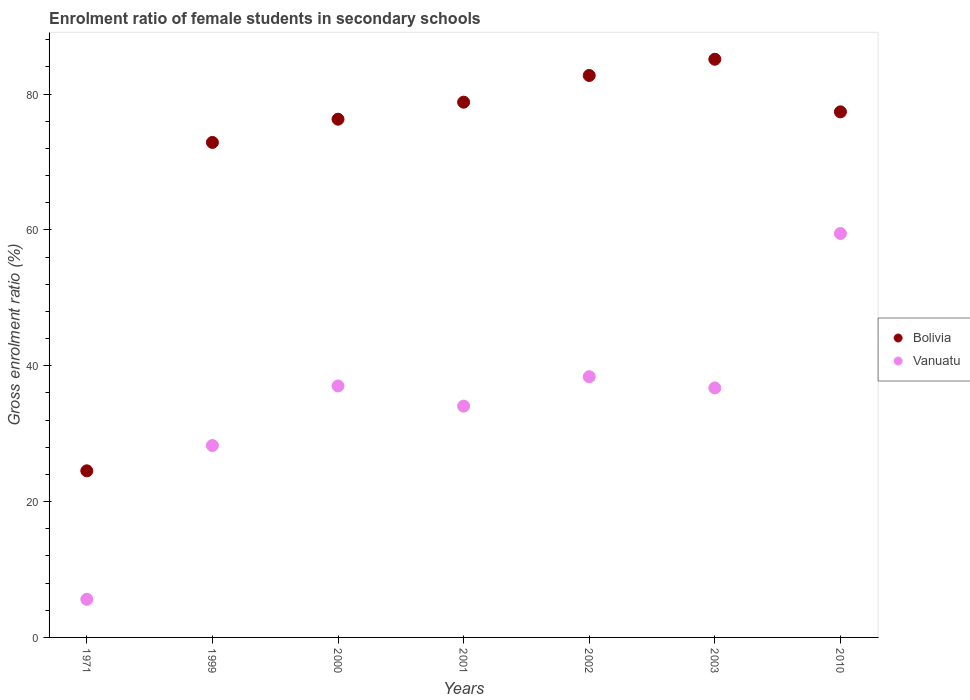Is the number of dotlines equal to the number of legend labels?
Provide a succinct answer. Yes. What is the enrolment ratio of female students in secondary schools in Bolivia in 2001?
Your answer should be very brief. 78.8. Across all years, what is the maximum enrolment ratio of female students in secondary schools in Vanuatu?
Provide a succinct answer. 59.47. Across all years, what is the minimum enrolment ratio of female students in secondary schools in Vanuatu?
Make the answer very short. 5.61. In which year was the enrolment ratio of female students in secondary schools in Bolivia minimum?
Your response must be concise. 1971. What is the total enrolment ratio of female students in secondary schools in Vanuatu in the graph?
Make the answer very short. 239.53. What is the difference between the enrolment ratio of female students in secondary schools in Bolivia in 2000 and that in 2001?
Ensure brevity in your answer.  -2.51. What is the difference between the enrolment ratio of female students in secondary schools in Vanuatu in 1971 and the enrolment ratio of female students in secondary schools in Bolivia in 2001?
Provide a succinct answer. -73.19. What is the average enrolment ratio of female students in secondary schools in Bolivia per year?
Provide a succinct answer. 71.1. In the year 2002, what is the difference between the enrolment ratio of female students in secondary schools in Vanuatu and enrolment ratio of female students in secondary schools in Bolivia?
Make the answer very short. -44.35. In how many years, is the enrolment ratio of female students in secondary schools in Bolivia greater than 8 %?
Your answer should be very brief. 7. What is the ratio of the enrolment ratio of female students in secondary schools in Vanuatu in 2003 to that in 2010?
Keep it short and to the point. 0.62. Is the difference between the enrolment ratio of female students in secondary schools in Vanuatu in 2001 and 2003 greater than the difference between the enrolment ratio of female students in secondary schools in Bolivia in 2001 and 2003?
Your response must be concise. Yes. What is the difference between the highest and the second highest enrolment ratio of female students in secondary schools in Vanuatu?
Give a very brief answer. 21.08. What is the difference between the highest and the lowest enrolment ratio of female students in secondary schools in Bolivia?
Your answer should be compact. 60.59. In how many years, is the enrolment ratio of female students in secondary schools in Vanuatu greater than the average enrolment ratio of female students in secondary schools in Vanuatu taken over all years?
Your answer should be compact. 4. Is the sum of the enrolment ratio of female students in secondary schools in Bolivia in 2000 and 2010 greater than the maximum enrolment ratio of female students in secondary schools in Vanuatu across all years?
Keep it short and to the point. Yes. Does the enrolment ratio of female students in secondary schools in Vanuatu monotonically increase over the years?
Make the answer very short. No. How many dotlines are there?
Your answer should be compact. 2. How many years are there in the graph?
Your answer should be very brief. 7. Are the values on the major ticks of Y-axis written in scientific E-notation?
Offer a terse response. No. Does the graph contain grids?
Make the answer very short. No. Where does the legend appear in the graph?
Make the answer very short. Center right. How many legend labels are there?
Keep it short and to the point. 2. What is the title of the graph?
Keep it short and to the point. Enrolment ratio of female students in secondary schools. What is the label or title of the X-axis?
Your answer should be very brief. Years. What is the label or title of the Y-axis?
Your answer should be very brief. Gross enrolment ratio (%). What is the Gross enrolment ratio (%) in Bolivia in 1971?
Make the answer very short. 24.53. What is the Gross enrolment ratio (%) in Vanuatu in 1971?
Offer a very short reply. 5.61. What is the Gross enrolment ratio (%) of Bolivia in 1999?
Give a very brief answer. 72.88. What is the Gross enrolment ratio (%) of Vanuatu in 1999?
Offer a very short reply. 28.25. What is the Gross enrolment ratio (%) in Bolivia in 2000?
Provide a succinct answer. 76.3. What is the Gross enrolment ratio (%) of Vanuatu in 2000?
Your answer should be very brief. 37.02. What is the Gross enrolment ratio (%) in Bolivia in 2001?
Give a very brief answer. 78.8. What is the Gross enrolment ratio (%) in Vanuatu in 2001?
Give a very brief answer. 34.05. What is the Gross enrolment ratio (%) in Bolivia in 2002?
Your response must be concise. 82.73. What is the Gross enrolment ratio (%) of Vanuatu in 2002?
Keep it short and to the point. 38.38. What is the Gross enrolment ratio (%) in Bolivia in 2003?
Give a very brief answer. 85.12. What is the Gross enrolment ratio (%) of Vanuatu in 2003?
Your response must be concise. 36.73. What is the Gross enrolment ratio (%) in Bolivia in 2010?
Your answer should be compact. 77.38. What is the Gross enrolment ratio (%) of Vanuatu in 2010?
Give a very brief answer. 59.47. Across all years, what is the maximum Gross enrolment ratio (%) of Bolivia?
Your response must be concise. 85.12. Across all years, what is the maximum Gross enrolment ratio (%) of Vanuatu?
Your response must be concise. 59.47. Across all years, what is the minimum Gross enrolment ratio (%) in Bolivia?
Your response must be concise. 24.53. Across all years, what is the minimum Gross enrolment ratio (%) of Vanuatu?
Provide a succinct answer. 5.61. What is the total Gross enrolment ratio (%) of Bolivia in the graph?
Your response must be concise. 497.73. What is the total Gross enrolment ratio (%) of Vanuatu in the graph?
Make the answer very short. 239.53. What is the difference between the Gross enrolment ratio (%) in Bolivia in 1971 and that in 1999?
Offer a very short reply. -48.35. What is the difference between the Gross enrolment ratio (%) of Vanuatu in 1971 and that in 1999?
Offer a terse response. -22.64. What is the difference between the Gross enrolment ratio (%) in Bolivia in 1971 and that in 2000?
Offer a terse response. -51.77. What is the difference between the Gross enrolment ratio (%) in Vanuatu in 1971 and that in 2000?
Make the answer very short. -31.41. What is the difference between the Gross enrolment ratio (%) in Bolivia in 1971 and that in 2001?
Make the answer very short. -54.27. What is the difference between the Gross enrolment ratio (%) in Vanuatu in 1971 and that in 2001?
Offer a very short reply. -28.44. What is the difference between the Gross enrolment ratio (%) in Bolivia in 1971 and that in 2002?
Offer a very short reply. -58.2. What is the difference between the Gross enrolment ratio (%) in Vanuatu in 1971 and that in 2002?
Your answer should be very brief. -32.77. What is the difference between the Gross enrolment ratio (%) in Bolivia in 1971 and that in 2003?
Offer a terse response. -60.59. What is the difference between the Gross enrolment ratio (%) in Vanuatu in 1971 and that in 2003?
Provide a short and direct response. -31.12. What is the difference between the Gross enrolment ratio (%) in Bolivia in 1971 and that in 2010?
Offer a terse response. -52.85. What is the difference between the Gross enrolment ratio (%) of Vanuatu in 1971 and that in 2010?
Your answer should be compact. -53.86. What is the difference between the Gross enrolment ratio (%) in Bolivia in 1999 and that in 2000?
Offer a terse response. -3.42. What is the difference between the Gross enrolment ratio (%) of Vanuatu in 1999 and that in 2000?
Your answer should be compact. -8.77. What is the difference between the Gross enrolment ratio (%) of Bolivia in 1999 and that in 2001?
Keep it short and to the point. -5.93. What is the difference between the Gross enrolment ratio (%) of Vanuatu in 1999 and that in 2001?
Your response must be concise. -5.8. What is the difference between the Gross enrolment ratio (%) of Bolivia in 1999 and that in 2002?
Your response must be concise. -9.86. What is the difference between the Gross enrolment ratio (%) in Vanuatu in 1999 and that in 2002?
Make the answer very short. -10.13. What is the difference between the Gross enrolment ratio (%) in Bolivia in 1999 and that in 2003?
Ensure brevity in your answer.  -12.25. What is the difference between the Gross enrolment ratio (%) of Vanuatu in 1999 and that in 2003?
Provide a succinct answer. -8.48. What is the difference between the Gross enrolment ratio (%) in Bolivia in 1999 and that in 2010?
Your answer should be compact. -4.5. What is the difference between the Gross enrolment ratio (%) of Vanuatu in 1999 and that in 2010?
Your answer should be very brief. -31.21. What is the difference between the Gross enrolment ratio (%) of Bolivia in 2000 and that in 2001?
Your answer should be very brief. -2.51. What is the difference between the Gross enrolment ratio (%) in Vanuatu in 2000 and that in 2001?
Give a very brief answer. 2.97. What is the difference between the Gross enrolment ratio (%) of Bolivia in 2000 and that in 2002?
Provide a succinct answer. -6.44. What is the difference between the Gross enrolment ratio (%) in Vanuatu in 2000 and that in 2002?
Your answer should be compact. -1.36. What is the difference between the Gross enrolment ratio (%) of Bolivia in 2000 and that in 2003?
Your answer should be very brief. -8.83. What is the difference between the Gross enrolment ratio (%) of Vanuatu in 2000 and that in 2003?
Provide a short and direct response. 0.29. What is the difference between the Gross enrolment ratio (%) of Bolivia in 2000 and that in 2010?
Offer a very short reply. -1.08. What is the difference between the Gross enrolment ratio (%) in Vanuatu in 2000 and that in 2010?
Make the answer very short. -22.44. What is the difference between the Gross enrolment ratio (%) of Bolivia in 2001 and that in 2002?
Your response must be concise. -3.93. What is the difference between the Gross enrolment ratio (%) of Vanuatu in 2001 and that in 2002?
Keep it short and to the point. -4.33. What is the difference between the Gross enrolment ratio (%) in Bolivia in 2001 and that in 2003?
Provide a succinct answer. -6.32. What is the difference between the Gross enrolment ratio (%) of Vanuatu in 2001 and that in 2003?
Provide a succinct answer. -2.68. What is the difference between the Gross enrolment ratio (%) of Bolivia in 2001 and that in 2010?
Give a very brief answer. 1.43. What is the difference between the Gross enrolment ratio (%) of Vanuatu in 2001 and that in 2010?
Provide a succinct answer. -25.42. What is the difference between the Gross enrolment ratio (%) in Bolivia in 2002 and that in 2003?
Offer a very short reply. -2.39. What is the difference between the Gross enrolment ratio (%) of Vanuatu in 2002 and that in 2003?
Provide a short and direct response. 1.65. What is the difference between the Gross enrolment ratio (%) of Bolivia in 2002 and that in 2010?
Provide a succinct answer. 5.36. What is the difference between the Gross enrolment ratio (%) of Vanuatu in 2002 and that in 2010?
Your response must be concise. -21.08. What is the difference between the Gross enrolment ratio (%) in Bolivia in 2003 and that in 2010?
Provide a short and direct response. 7.75. What is the difference between the Gross enrolment ratio (%) of Vanuatu in 2003 and that in 2010?
Offer a terse response. -22.74. What is the difference between the Gross enrolment ratio (%) in Bolivia in 1971 and the Gross enrolment ratio (%) in Vanuatu in 1999?
Ensure brevity in your answer.  -3.73. What is the difference between the Gross enrolment ratio (%) of Bolivia in 1971 and the Gross enrolment ratio (%) of Vanuatu in 2000?
Provide a succinct answer. -12.5. What is the difference between the Gross enrolment ratio (%) of Bolivia in 1971 and the Gross enrolment ratio (%) of Vanuatu in 2001?
Your response must be concise. -9.53. What is the difference between the Gross enrolment ratio (%) of Bolivia in 1971 and the Gross enrolment ratio (%) of Vanuatu in 2002?
Keep it short and to the point. -13.86. What is the difference between the Gross enrolment ratio (%) in Bolivia in 1971 and the Gross enrolment ratio (%) in Vanuatu in 2003?
Your answer should be compact. -12.21. What is the difference between the Gross enrolment ratio (%) in Bolivia in 1971 and the Gross enrolment ratio (%) in Vanuatu in 2010?
Ensure brevity in your answer.  -34.94. What is the difference between the Gross enrolment ratio (%) in Bolivia in 1999 and the Gross enrolment ratio (%) in Vanuatu in 2000?
Keep it short and to the point. 35.85. What is the difference between the Gross enrolment ratio (%) in Bolivia in 1999 and the Gross enrolment ratio (%) in Vanuatu in 2001?
Offer a very short reply. 38.82. What is the difference between the Gross enrolment ratio (%) in Bolivia in 1999 and the Gross enrolment ratio (%) in Vanuatu in 2002?
Offer a very short reply. 34.49. What is the difference between the Gross enrolment ratio (%) of Bolivia in 1999 and the Gross enrolment ratio (%) of Vanuatu in 2003?
Provide a succinct answer. 36.14. What is the difference between the Gross enrolment ratio (%) in Bolivia in 1999 and the Gross enrolment ratio (%) in Vanuatu in 2010?
Offer a terse response. 13.41. What is the difference between the Gross enrolment ratio (%) of Bolivia in 2000 and the Gross enrolment ratio (%) of Vanuatu in 2001?
Your response must be concise. 42.24. What is the difference between the Gross enrolment ratio (%) in Bolivia in 2000 and the Gross enrolment ratio (%) in Vanuatu in 2002?
Make the answer very short. 37.91. What is the difference between the Gross enrolment ratio (%) in Bolivia in 2000 and the Gross enrolment ratio (%) in Vanuatu in 2003?
Your answer should be compact. 39.56. What is the difference between the Gross enrolment ratio (%) in Bolivia in 2000 and the Gross enrolment ratio (%) in Vanuatu in 2010?
Ensure brevity in your answer.  16.83. What is the difference between the Gross enrolment ratio (%) of Bolivia in 2001 and the Gross enrolment ratio (%) of Vanuatu in 2002?
Offer a very short reply. 40.42. What is the difference between the Gross enrolment ratio (%) of Bolivia in 2001 and the Gross enrolment ratio (%) of Vanuatu in 2003?
Keep it short and to the point. 42.07. What is the difference between the Gross enrolment ratio (%) of Bolivia in 2001 and the Gross enrolment ratio (%) of Vanuatu in 2010?
Give a very brief answer. 19.33. What is the difference between the Gross enrolment ratio (%) in Bolivia in 2002 and the Gross enrolment ratio (%) in Vanuatu in 2003?
Your response must be concise. 46. What is the difference between the Gross enrolment ratio (%) in Bolivia in 2002 and the Gross enrolment ratio (%) in Vanuatu in 2010?
Offer a terse response. 23.26. What is the difference between the Gross enrolment ratio (%) in Bolivia in 2003 and the Gross enrolment ratio (%) in Vanuatu in 2010?
Make the answer very short. 25.65. What is the average Gross enrolment ratio (%) in Bolivia per year?
Offer a very short reply. 71.1. What is the average Gross enrolment ratio (%) in Vanuatu per year?
Provide a succinct answer. 34.22. In the year 1971, what is the difference between the Gross enrolment ratio (%) of Bolivia and Gross enrolment ratio (%) of Vanuatu?
Provide a short and direct response. 18.91. In the year 1999, what is the difference between the Gross enrolment ratio (%) of Bolivia and Gross enrolment ratio (%) of Vanuatu?
Provide a succinct answer. 44.62. In the year 2000, what is the difference between the Gross enrolment ratio (%) in Bolivia and Gross enrolment ratio (%) in Vanuatu?
Ensure brevity in your answer.  39.27. In the year 2001, what is the difference between the Gross enrolment ratio (%) of Bolivia and Gross enrolment ratio (%) of Vanuatu?
Offer a terse response. 44.75. In the year 2002, what is the difference between the Gross enrolment ratio (%) in Bolivia and Gross enrolment ratio (%) in Vanuatu?
Give a very brief answer. 44.35. In the year 2003, what is the difference between the Gross enrolment ratio (%) of Bolivia and Gross enrolment ratio (%) of Vanuatu?
Keep it short and to the point. 48.39. In the year 2010, what is the difference between the Gross enrolment ratio (%) in Bolivia and Gross enrolment ratio (%) in Vanuatu?
Keep it short and to the point. 17.91. What is the ratio of the Gross enrolment ratio (%) in Bolivia in 1971 to that in 1999?
Keep it short and to the point. 0.34. What is the ratio of the Gross enrolment ratio (%) in Vanuatu in 1971 to that in 1999?
Offer a very short reply. 0.2. What is the ratio of the Gross enrolment ratio (%) of Bolivia in 1971 to that in 2000?
Your answer should be compact. 0.32. What is the ratio of the Gross enrolment ratio (%) of Vanuatu in 1971 to that in 2000?
Your response must be concise. 0.15. What is the ratio of the Gross enrolment ratio (%) in Bolivia in 1971 to that in 2001?
Offer a terse response. 0.31. What is the ratio of the Gross enrolment ratio (%) of Vanuatu in 1971 to that in 2001?
Provide a short and direct response. 0.16. What is the ratio of the Gross enrolment ratio (%) of Bolivia in 1971 to that in 2002?
Your response must be concise. 0.3. What is the ratio of the Gross enrolment ratio (%) in Vanuatu in 1971 to that in 2002?
Ensure brevity in your answer.  0.15. What is the ratio of the Gross enrolment ratio (%) of Bolivia in 1971 to that in 2003?
Your answer should be compact. 0.29. What is the ratio of the Gross enrolment ratio (%) in Vanuatu in 1971 to that in 2003?
Your answer should be very brief. 0.15. What is the ratio of the Gross enrolment ratio (%) of Bolivia in 1971 to that in 2010?
Keep it short and to the point. 0.32. What is the ratio of the Gross enrolment ratio (%) of Vanuatu in 1971 to that in 2010?
Keep it short and to the point. 0.09. What is the ratio of the Gross enrolment ratio (%) of Bolivia in 1999 to that in 2000?
Your answer should be very brief. 0.96. What is the ratio of the Gross enrolment ratio (%) of Vanuatu in 1999 to that in 2000?
Provide a short and direct response. 0.76. What is the ratio of the Gross enrolment ratio (%) of Bolivia in 1999 to that in 2001?
Your answer should be compact. 0.92. What is the ratio of the Gross enrolment ratio (%) of Vanuatu in 1999 to that in 2001?
Provide a short and direct response. 0.83. What is the ratio of the Gross enrolment ratio (%) in Bolivia in 1999 to that in 2002?
Provide a succinct answer. 0.88. What is the ratio of the Gross enrolment ratio (%) of Vanuatu in 1999 to that in 2002?
Your response must be concise. 0.74. What is the ratio of the Gross enrolment ratio (%) in Bolivia in 1999 to that in 2003?
Your answer should be compact. 0.86. What is the ratio of the Gross enrolment ratio (%) in Vanuatu in 1999 to that in 2003?
Your answer should be compact. 0.77. What is the ratio of the Gross enrolment ratio (%) of Bolivia in 1999 to that in 2010?
Keep it short and to the point. 0.94. What is the ratio of the Gross enrolment ratio (%) in Vanuatu in 1999 to that in 2010?
Offer a terse response. 0.48. What is the ratio of the Gross enrolment ratio (%) of Bolivia in 2000 to that in 2001?
Make the answer very short. 0.97. What is the ratio of the Gross enrolment ratio (%) of Vanuatu in 2000 to that in 2001?
Give a very brief answer. 1.09. What is the ratio of the Gross enrolment ratio (%) of Bolivia in 2000 to that in 2002?
Give a very brief answer. 0.92. What is the ratio of the Gross enrolment ratio (%) in Vanuatu in 2000 to that in 2002?
Make the answer very short. 0.96. What is the ratio of the Gross enrolment ratio (%) of Bolivia in 2000 to that in 2003?
Your answer should be compact. 0.9. What is the ratio of the Gross enrolment ratio (%) in Bolivia in 2000 to that in 2010?
Make the answer very short. 0.99. What is the ratio of the Gross enrolment ratio (%) of Vanuatu in 2000 to that in 2010?
Your answer should be very brief. 0.62. What is the ratio of the Gross enrolment ratio (%) of Bolivia in 2001 to that in 2002?
Offer a terse response. 0.95. What is the ratio of the Gross enrolment ratio (%) of Vanuatu in 2001 to that in 2002?
Keep it short and to the point. 0.89. What is the ratio of the Gross enrolment ratio (%) of Bolivia in 2001 to that in 2003?
Provide a short and direct response. 0.93. What is the ratio of the Gross enrolment ratio (%) in Vanuatu in 2001 to that in 2003?
Provide a succinct answer. 0.93. What is the ratio of the Gross enrolment ratio (%) in Bolivia in 2001 to that in 2010?
Ensure brevity in your answer.  1.02. What is the ratio of the Gross enrolment ratio (%) in Vanuatu in 2001 to that in 2010?
Your response must be concise. 0.57. What is the ratio of the Gross enrolment ratio (%) of Bolivia in 2002 to that in 2003?
Provide a succinct answer. 0.97. What is the ratio of the Gross enrolment ratio (%) in Vanuatu in 2002 to that in 2003?
Ensure brevity in your answer.  1.04. What is the ratio of the Gross enrolment ratio (%) in Bolivia in 2002 to that in 2010?
Give a very brief answer. 1.07. What is the ratio of the Gross enrolment ratio (%) in Vanuatu in 2002 to that in 2010?
Provide a short and direct response. 0.65. What is the ratio of the Gross enrolment ratio (%) of Bolivia in 2003 to that in 2010?
Make the answer very short. 1.1. What is the ratio of the Gross enrolment ratio (%) of Vanuatu in 2003 to that in 2010?
Your response must be concise. 0.62. What is the difference between the highest and the second highest Gross enrolment ratio (%) of Bolivia?
Keep it short and to the point. 2.39. What is the difference between the highest and the second highest Gross enrolment ratio (%) of Vanuatu?
Ensure brevity in your answer.  21.08. What is the difference between the highest and the lowest Gross enrolment ratio (%) in Bolivia?
Your answer should be very brief. 60.59. What is the difference between the highest and the lowest Gross enrolment ratio (%) of Vanuatu?
Offer a terse response. 53.86. 